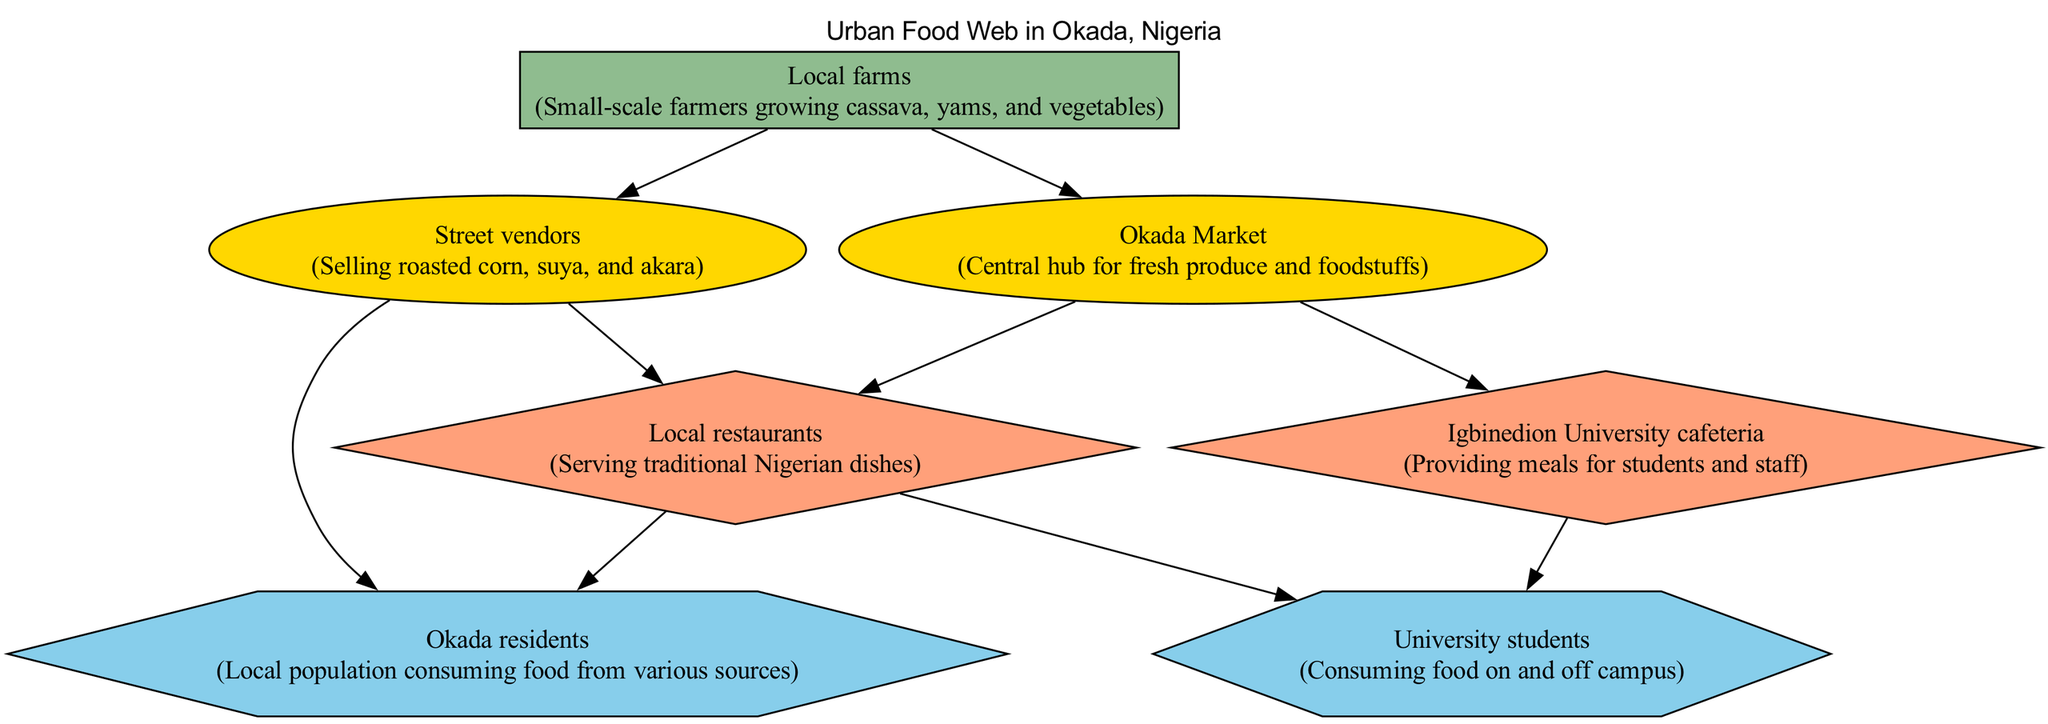What are the primary consumers in this urban food web? The primary consumers are the entities that directly consume the producers. In this diagram, the primary consumers identified are the "Street vendors" and the "Okada Market."
Answer: Street vendors, Okada Market How many nodes are there in the diagram? A node represents each element in the urban food web. By counting each distinct element in the diagram, we find there are 7 nodes in total: Local farms, Street vendors, Okada Market, Local restaurants, Igbinedion University cafeteria, Okada residents, University students.
Answer: 7 Which entities directly depend on Local farms for food? The diagram shows directed edges leading from Local farms to two elements, indicating they depend on it for food. The two entities are "Street vendors" and "Okada Market."
Answer: Street vendors, Okada Market What type of consumer is the Igbinedion University cafeteria? The Igbinedion University cafeteria is classified as a secondary consumer in the food web since it serves meals to students, deriving its food from the primary consumers.
Answer: Secondary consumer How many tertiary consumers are identified in this food web? Tertiary consumers are the entities that consume food from secondary consumers. In this diagram, there are two tertiary consumers: "Okada residents" and "University students." Counting these gives a total of two tertiary consumers.
Answer: 2 Which node serves meals specifically for students? The diagram indicates that the "Igbinedion University cafeteria" is dedicated to providing meals specifically for students and staff. Therefore, this is the node that serves meals for students.
Answer: Igbinedion University cafeteria What is the relationship between Street vendors and Local restaurants? The Street vendors supply food to Local restaurants, as evidenced by the directed edge leading from Street vendors to Local restaurants in the diagram, indicating dependency.
Answer: Street vendors supply food Which consumer category does the Okada Market fall under? The Okada Market is classified as a primary consumer in the food web, as it is directly dependent on the producer, Local farms, for fresh produce and foodstuffs.
Answer: Primary consumer What type of food do Local restaurants serve? According to the diagram, Local restaurants serve traditional Nigerian dishes, which identifies their primary function within the food web.
Answer: Traditional Nigerian dishes 